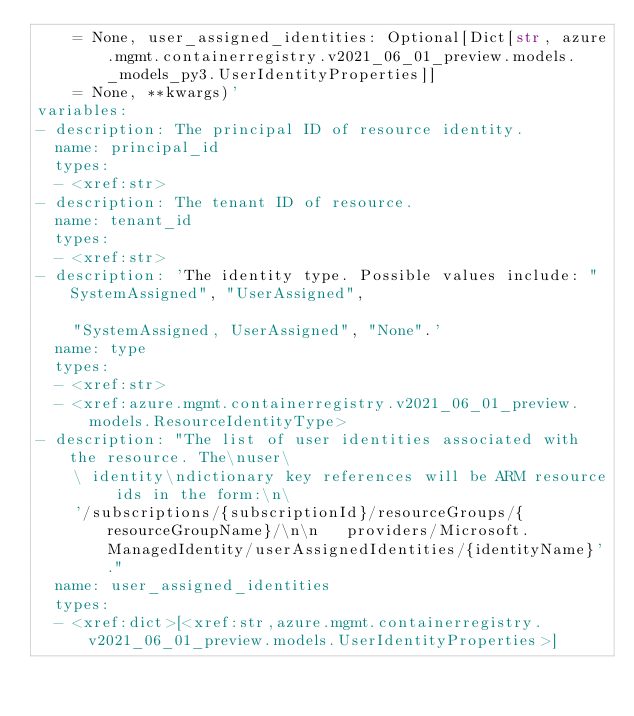<code> <loc_0><loc_0><loc_500><loc_500><_YAML_>    = None, user_assigned_identities: Optional[Dict[str, azure.mgmt.containerregistry.v2021_06_01_preview.models._models_py3.UserIdentityProperties]]
    = None, **kwargs)'
variables:
- description: The principal ID of resource identity.
  name: principal_id
  types:
  - <xref:str>
- description: The tenant ID of resource.
  name: tenant_id
  types:
  - <xref:str>
- description: 'The identity type. Possible values include: "SystemAssigned", "UserAssigned",

    "SystemAssigned, UserAssigned", "None".'
  name: type
  types:
  - <xref:str>
  - <xref:azure.mgmt.containerregistry.v2021_06_01_preview.models.ResourceIdentityType>
- description: "The list of user identities associated with the resource. The\nuser\
    \ identity\ndictionary key references will be ARM resource ids in the form:\n\
    '/subscriptions/{subscriptionId}/resourceGroups/{resourceGroupName}/\n\n   providers/Microsoft.ManagedIdentity/userAssignedIdentities/{identityName}'."
  name: user_assigned_identities
  types:
  - <xref:dict>[<xref:str,azure.mgmt.containerregistry.v2021_06_01_preview.models.UserIdentityProperties>]
</code> 